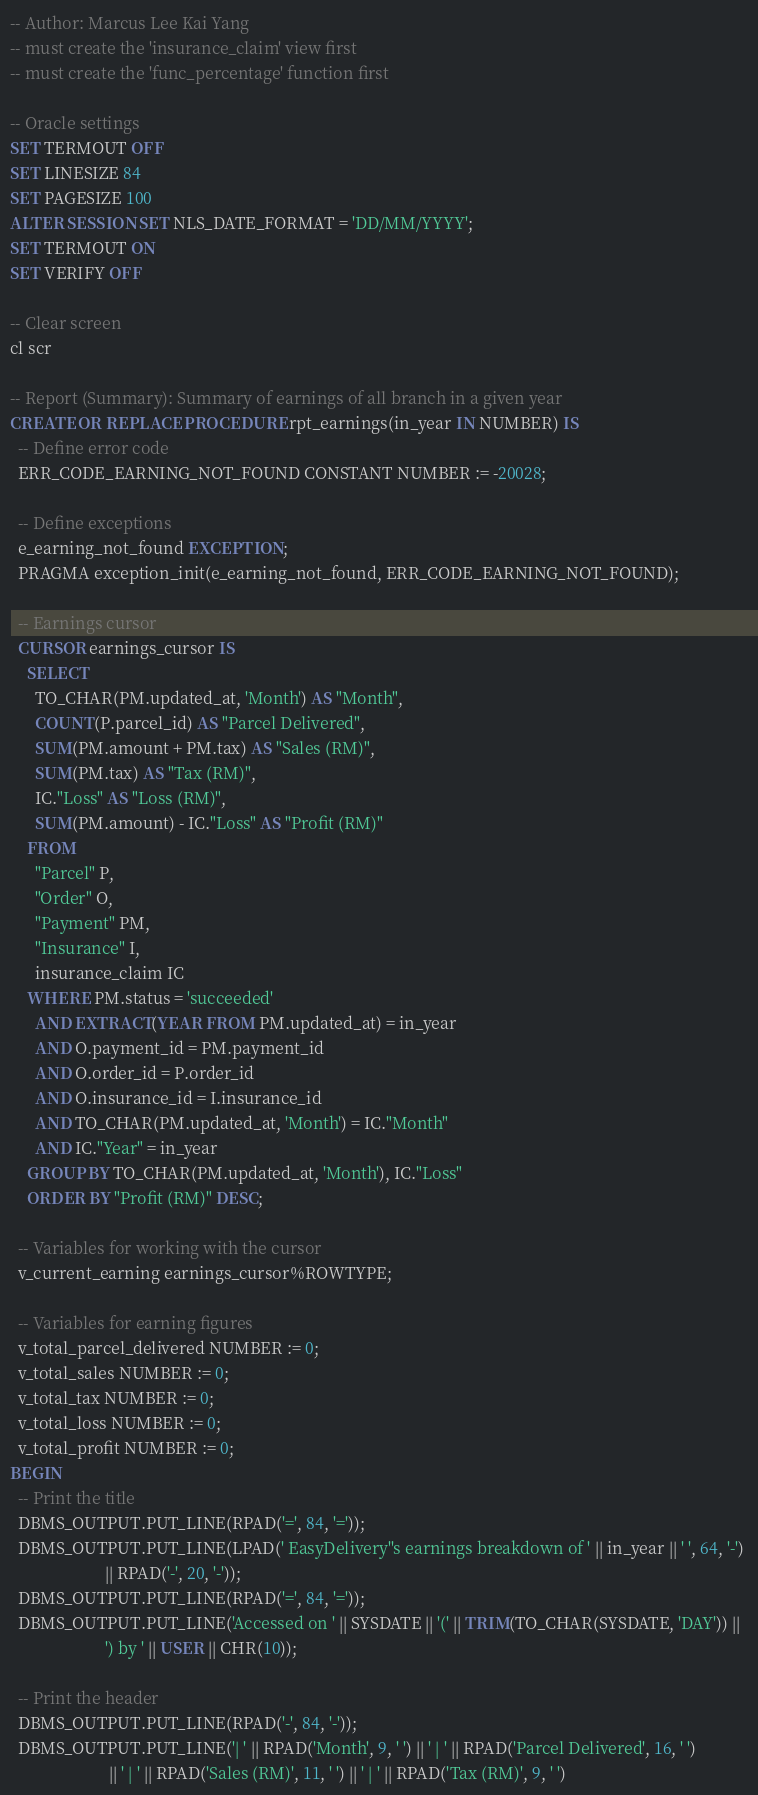<code> <loc_0><loc_0><loc_500><loc_500><_SQL_>-- Author: Marcus Lee Kai Yang
-- must create the 'insurance_claim' view first
-- must create the 'func_percentage' function first

-- Oracle settings
SET TERMOUT OFF 
SET LINESIZE 84
SET PAGESIZE 100
ALTER SESSION SET NLS_DATE_FORMAT = 'DD/MM/YYYY';
SET TERMOUT ON
SET VERIFY OFF

-- Clear screen
cl scr

-- Report (Summary): Summary of earnings of all branch in a given year
CREATE OR REPLACE PROCEDURE rpt_earnings(in_year IN NUMBER) IS 
  -- Define error code
  ERR_CODE_EARNING_NOT_FOUND CONSTANT NUMBER := -20028;

  -- Define exceptions
  e_earning_not_found EXCEPTION;
  PRAGMA exception_init(e_earning_not_found, ERR_CODE_EARNING_NOT_FOUND);

  -- Earnings cursor
  CURSOR earnings_cursor IS
    SELECT
      TO_CHAR(PM.updated_at, 'Month') AS "Month",
      COUNT(P.parcel_id) AS "Parcel Delivered",
      SUM(PM.amount + PM.tax) AS "Sales (RM)",
      SUM(PM.tax) AS "Tax (RM)",
      IC."Loss" AS "Loss (RM)",
      SUM(PM.amount) - IC."Loss" AS "Profit (RM)"
    FROM
      "Parcel" P, 
      "Order" O, 
      "Payment" PM, 
      "Insurance" I,
      insurance_claim IC
    WHERE PM.status = 'succeeded'
      AND EXTRACT(YEAR FROM PM.updated_at) = in_year
      AND O.payment_id = PM.payment_id
      AND O.order_id = P.order_id
      AND O.insurance_id = I.insurance_id
      AND TO_CHAR(PM.updated_at, 'Month') = IC."Month"
      AND IC."Year" = in_year
    GROUP BY TO_CHAR(PM.updated_at, 'Month'), IC."Loss"
    ORDER BY "Profit (RM)" DESC;

  -- Variables for working with the cursor
  v_current_earning earnings_cursor%ROWTYPE;

  -- Variables for earning figures
  v_total_parcel_delivered NUMBER := 0;
  v_total_sales NUMBER := 0;
  v_total_tax NUMBER := 0;
  v_total_loss NUMBER := 0;
  v_total_profit NUMBER := 0;
BEGIN
  -- Print the title
  DBMS_OUTPUT.PUT_LINE(RPAD('=', 84, '='));
  DBMS_OUTPUT.PUT_LINE(LPAD(' EasyDelivery''s earnings breakdown of ' || in_year || ' ', 64, '-') 
                       || RPAD('-', 20, '-'));
  DBMS_OUTPUT.PUT_LINE(RPAD('=', 84, '='));
  DBMS_OUTPUT.PUT_LINE('Accessed on ' || SYSDATE || '(' || TRIM(TO_CHAR(SYSDATE, 'DAY')) || 
                       ') by ' || USER || CHR(10));

  -- Print the header
  DBMS_OUTPUT.PUT_LINE(RPAD('-', 84, '-'));
  DBMS_OUTPUT.PUT_LINE('| ' || RPAD('Month', 9, ' ') || ' | ' || RPAD('Parcel Delivered', 16, ' ') 
                        || ' | ' || RPAD('Sales (RM)', 11, ' ') || ' | ' || RPAD('Tax (RM)', 9, ' ') </code> 